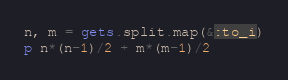Convert code to text. <code><loc_0><loc_0><loc_500><loc_500><_Ruby_>n, m = gets.split.map(&:to_i)
p n*(n-1)/2 + m*(m-1)/2</code> 